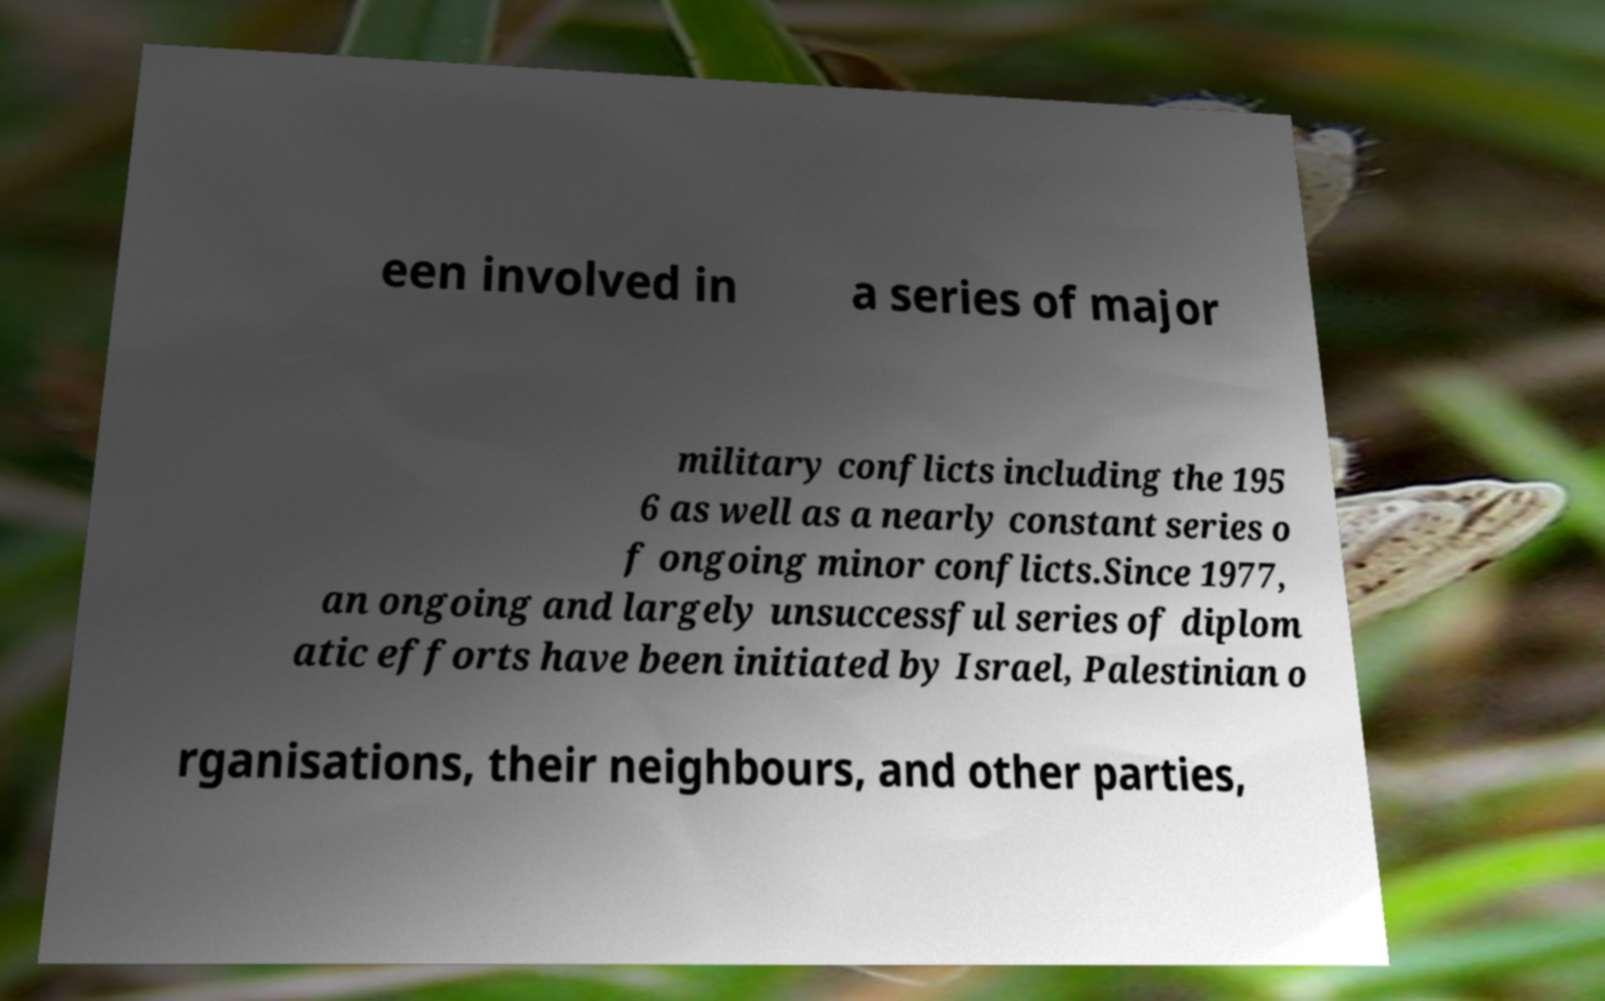For documentation purposes, I need the text within this image transcribed. Could you provide that? een involved in a series of major military conflicts including the 195 6 as well as a nearly constant series o f ongoing minor conflicts.Since 1977, an ongoing and largely unsuccessful series of diplom atic efforts have been initiated by Israel, Palestinian o rganisations, their neighbours, and other parties, 